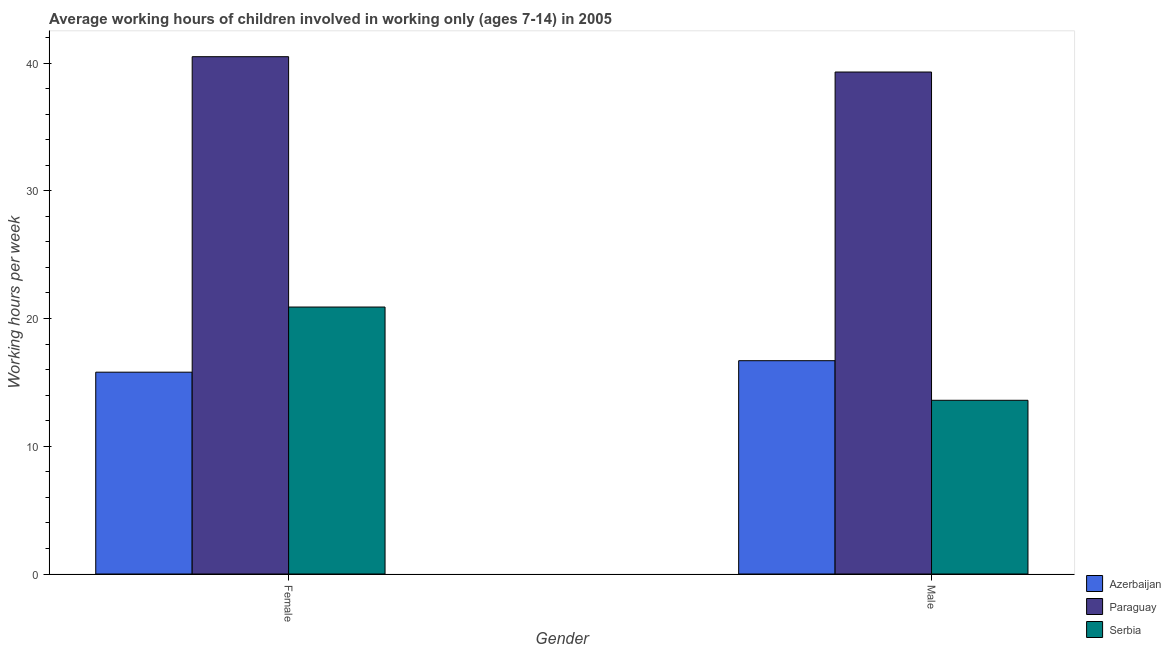How many different coloured bars are there?
Provide a succinct answer. 3. How many groups of bars are there?
Provide a short and direct response. 2. Are the number of bars on each tick of the X-axis equal?
Ensure brevity in your answer.  Yes. What is the label of the 1st group of bars from the left?
Provide a short and direct response. Female. What is the average working hour of male children in Serbia?
Offer a terse response. 13.6. Across all countries, what is the maximum average working hour of male children?
Offer a very short reply. 39.3. Across all countries, what is the minimum average working hour of male children?
Provide a succinct answer. 13.6. In which country was the average working hour of male children maximum?
Provide a succinct answer. Paraguay. In which country was the average working hour of male children minimum?
Your answer should be compact. Serbia. What is the total average working hour of female children in the graph?
Make the answer very short. 77.2. What is the difference between the average working hour of female children in Paraguay and that in Azerbaijan?
Your answer should be compact. 24.7. What is the difference between the average working hour of female children in Serbia and the average working hour of male children in Paraguay?
Give a very brief answer. -18.4. What is the average average working hour of female children per country?
Offer a very short reply. 25.73. What is the difference between the average working hour of male children and average working hour of female children in Paraguay?
Ensure brevity in your answer.  -1.2. In how many countries, is the average working hour of female children greater than 12 hours?
Provide a short and direct response. 3. What is the ratio of the average working hour of male children in Serbia to that in Paraguay?
Offer a very short reply. 0.35. Is the average working hour of male children in Paraguay less than that in Serbia?
Keep it short and to the point. No. In how many countries, is the average working hour of male children greater than the average average working hour of male children taken over all countries?
Provide a short and direct response. 1. What does the 2nd bar from the left in Male represents?
Your answer should be very brief. Paraguay. What does the 3rd bar from the right in Male represents?
Your response must be concise. Azerbaijan. How many countries are there in the graph?
Offer a terse response. 3. Are the values on the major ticks of Y-axis written in scientific E-notation?
Your answer should be compact. No. Does the graph contain grids?
Provide a succinct answer. No. Where does the legend appear in the graph?
Ensure brevity in your answer.  Bottom right. What is the title of the graph?
Offer a terse response. Average working hours of children involved in working only (ages 7-14) in 2005. Does "Arab World" appear as one of the legend labels in the graph?
Ensure brevity in your answer.  No. What is the label or title of the X-axis?
Offer a very short reply. Gender. What is the label or title of the Y-axis?
Offer a terse response. Working hours per week. What is the Working hours per week in Azerbaijan in Female?
Keep it short and to the point. 15.8. What is the Working hours per week of Paraguay in Female?
Provide a succinct answer. 40.5. What is the Working hours per week of Serbia in Female?
Offer a very short reply. 20.9. What is the Working hours per week of Azerbaijan in Male?
Keep it short and to the point. 16.7. What is the Working hours per week in Paraguay in Male?
Your answer should be very brief. 39.3. Across all Gender, what is the maximum Working hours per week of Paraguay?
Your answer should be compact. 40.5. Across all Gender, what is the maximum Working hours per week of Serbia?
Keep it short and to the point. 20.9. Across all Gender, what is the minimum Working hours per week in Paraguay?
Keep it short and to the point. 39.3. Across all Gender, what is the minimum Working hours per week of Serbia?
Make the answer very short. 13.6. What is the total Working hours per week of Azerbaijan in the graph?
Make the answer very short. 32.5. What is the total Working hours per week in Paraguay in the graph?
Offer a terse response. 79.8. What is the total Working hours per week in Serbia in the graph?
Keep it short and to the point. 34.5. What is the difference between the Working hours per week of Azerbaijan in Female and that in Male?
Your answer should be compact. -0.9. What is the difference between the Working hours per week in Serbia in Female and that in Male?
Your response must be concise. 7.3. What is the difference between the Working hours per week in Azerbaijan in Female and the Working hours per week in Paraguay in Male?
Offer a very short reply. -23.5. What is the difference between the Working hours per week of Paraguay in Female and the Working hours per week of Serbia in Male?
Provide a succinct answer. 26.9. What is the average Working hours per week of Azerbaijan per Gender?
Ensure brevity in your answer.  16.25. What is the average Working hours per week of Paraguay per Gender?
Provide a succinct answer. 39.9. What is the average Working hours per week in Serbia per Gender?
Offer a terse response. 17.25. What is the difference between the Working hours per week in Azerbaijan and Working hours per week in Paraguay in Female?
Give a very brief answer. -24.7. What is the difference between the Working hours per week of Azerbaijan and Working hours per week of Serbia in Female?
Your answer should be very brief. -5.1. What is the difference between the Working hours per week of Paraguay and Working hours per week of Serbia in Female?
Your response must be concise. 19.6. What is the difference between the Working hours per week of Azerbaijan and Working hours per week of Paraguay in Male?
Offer a terse response. -22.6. What is the difference between the Working hours per week of Paraguay and Working hours per week of Serbia in Male?
Keep it short and to the point. 25.7. What is the ratio of the Working hours per week in Azerbaijan in Female to that in Male?
Ensure brevity in your answer.  0.95. What is the ratio of the Working hours per week in Paraguay in Female to that in Male?
Your answer should be compact. 1.03. What is the ratio of the Working hours per week in Serbia in Female to that in Male?
Make the answer very short. 1.54. What is the difference between the highest and the second highest Working hours per week of Azerbaijan?
Keep it short and to the point. 0.9. What is the difference between the highest and the second highest Working hours per week of Paraguay?
Keep it short and to the point. 1.2. What is the difference between the highest and the second highest Working hours per week in Serbia?
Provide a succinct answer. 7.3. What is the difference between the highest and the lowest Working hours per week in Serbia?
Ensure brevity in your answer.  7.3. 